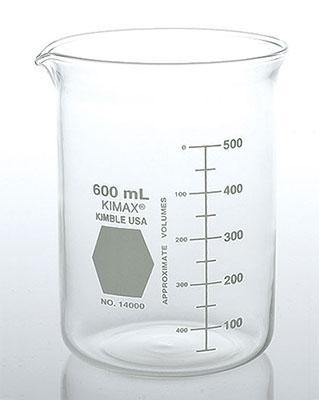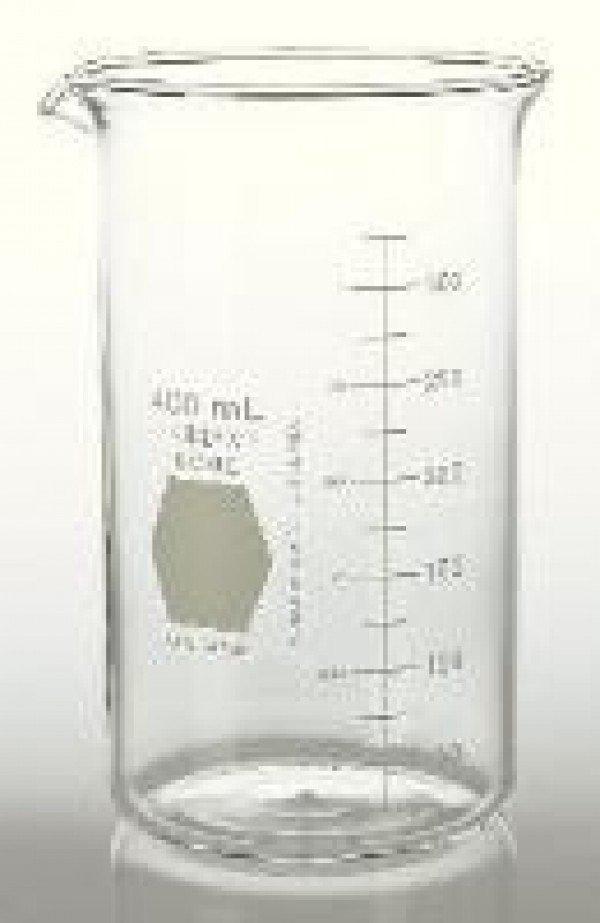The first image is the image on the left, the second image is the image on the right. Given the left and right images, does the statement "One beaker has a gray hexagon shape next to its volume line, and the other beaker has a square shape." hold true? Answer yes or no. No. The first image is the image on the left, the second image is the image on the right. Evaluate the accuracy of this statement regarding the images: "There are two beakers facing left with one hexagon and one square printed on the beaker.". Is it true? Answer yes or no. No. 